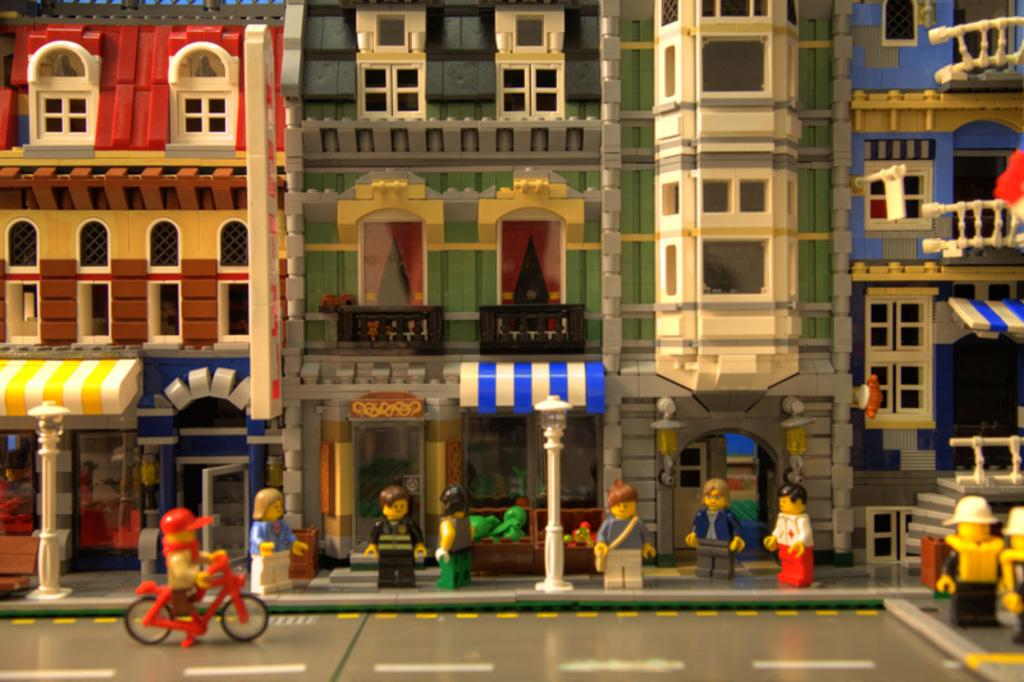What type of toy is featured in the image? The image contains Lego pieces. What structures are made from the Lego pieces? There are toy buildings made of Lego. Are there any Lego figures in the image? Yes, there are toy people made of Lego at the bottom side of the image. What type of lumber is being used to construct the toy buildings in the image? There is no lumber present in the image; the toy buildings are made entirely of Lego pieces. What type of utensil is being used by the Lego figures in the image? There are no utensils, such as forks, present in the image; the Lego figures are not depicted using any objects. 